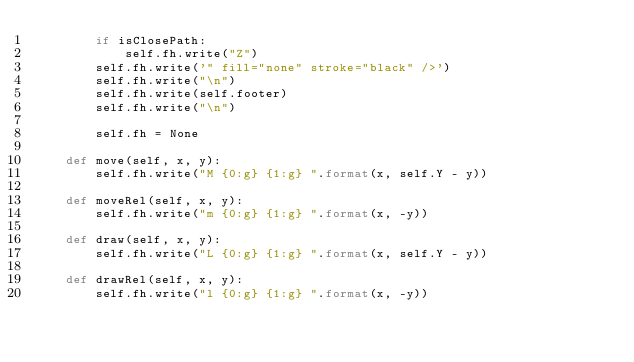<code> <loc_0><loc_0><loc_500><loc_500><_Python_>        if isClosePath:
            self.fh.write("Z")
        self.fh.write('" fill="none" stroke="black" />')
        self.fh.write("\n")
        self.fh.write(self.footer)
        self.fh.write("\n")

        self.fh = None

    def move(self, x, y):
        self.fh.write("M {0:g} {1:g} ".format(x, self.Y - y))

    def moveRel(self, x, y):
        self.fh.write("m {0:g} {1:g} ".format(x, -y))

    def draw(self, x, y):
        self.fh.write("L {0:g} {1:g} ".format(x, self.Y - y))

    def drawRel(self, x, y):
        self.fh.write("l {0:g} {1:g} ".format(x, -y))
</code> 